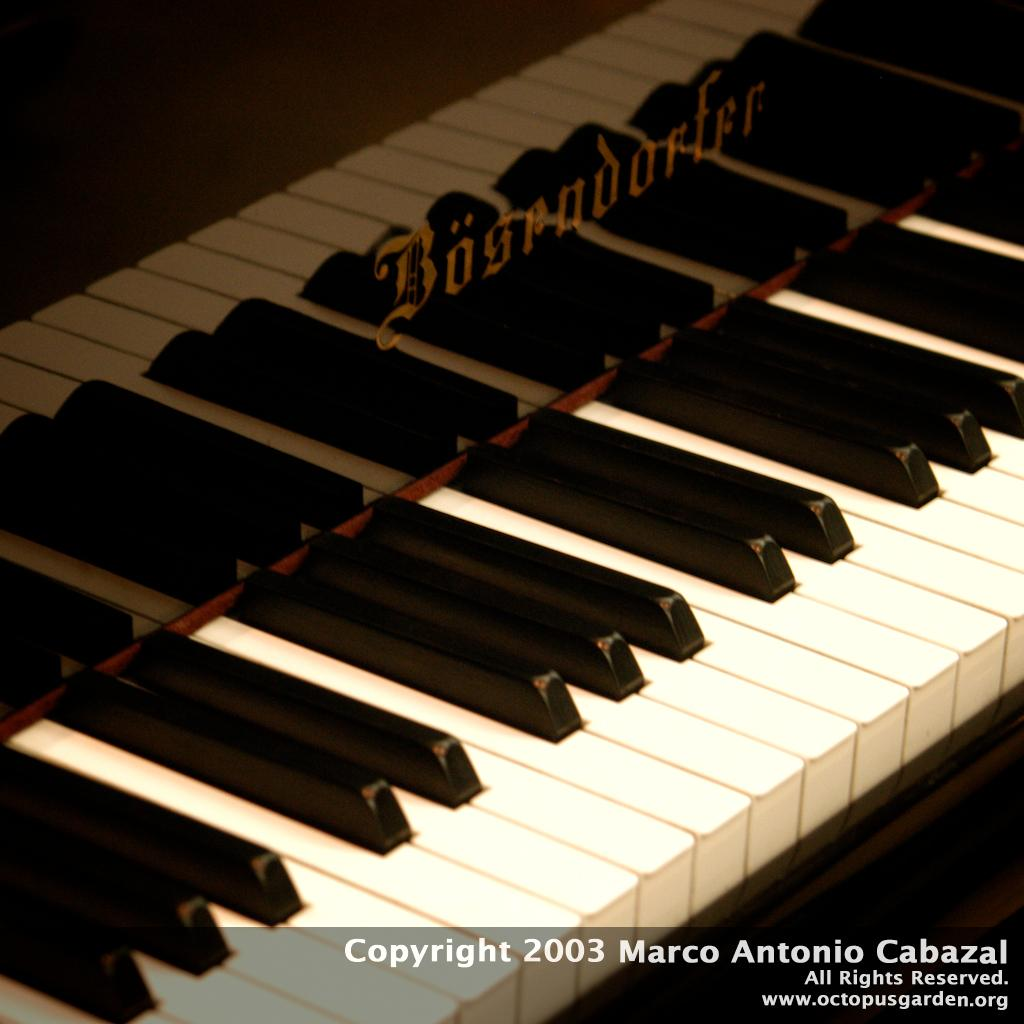What musical instrument is featured in the image? There is a piano keyboard in the image. What part of the piano is visible in the image? The piano keyboard is visible in the image. What type of stem can be seen growing from the sofa in the image? There is no sofa or stem present in the image; it only features a piano keyboard. 